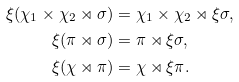<formula> <loc_0><loc_0><loc_500><loc_500>\xi ( \chi _ { 1 } \times \chi _ { 2 } \rtimes \sigma ) & = \chi _ { 1 } \times \chi _ { 2 } \rtimes \xi \sigma , \\ \xi ( \pi \rtimes \sigma ) & = \pi \rtimes \xi \sigma , \\ \xi ( \chi \rtimes \pi ) & = \chi \rtimes \xi \pi .</formula> 